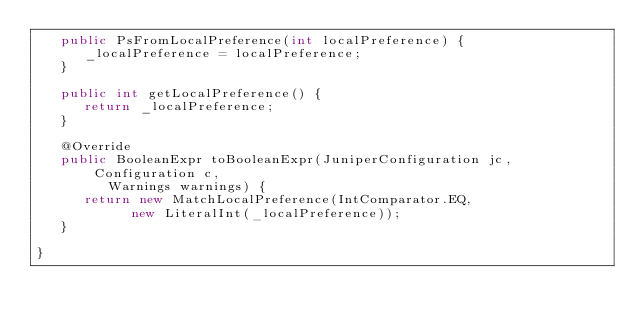<code> <loc_0><loc_0><loc_500><loc_500><_Java_>   public PsFromLocalPreference(int localPreference) {
      _localPreference = localPreference;
   }

   public int getLocalPreference() {
      return _localPreference;
   }

   @Override
   public BooleanExpr toBooleanExpr(JuniperConfiguration jc, Configuration c,
         Warnings warnings) {
      return new MatchLocalPreference(IntComparator.EQ,
            new LiteralInt(_localPreference));
   }

}
</code> 